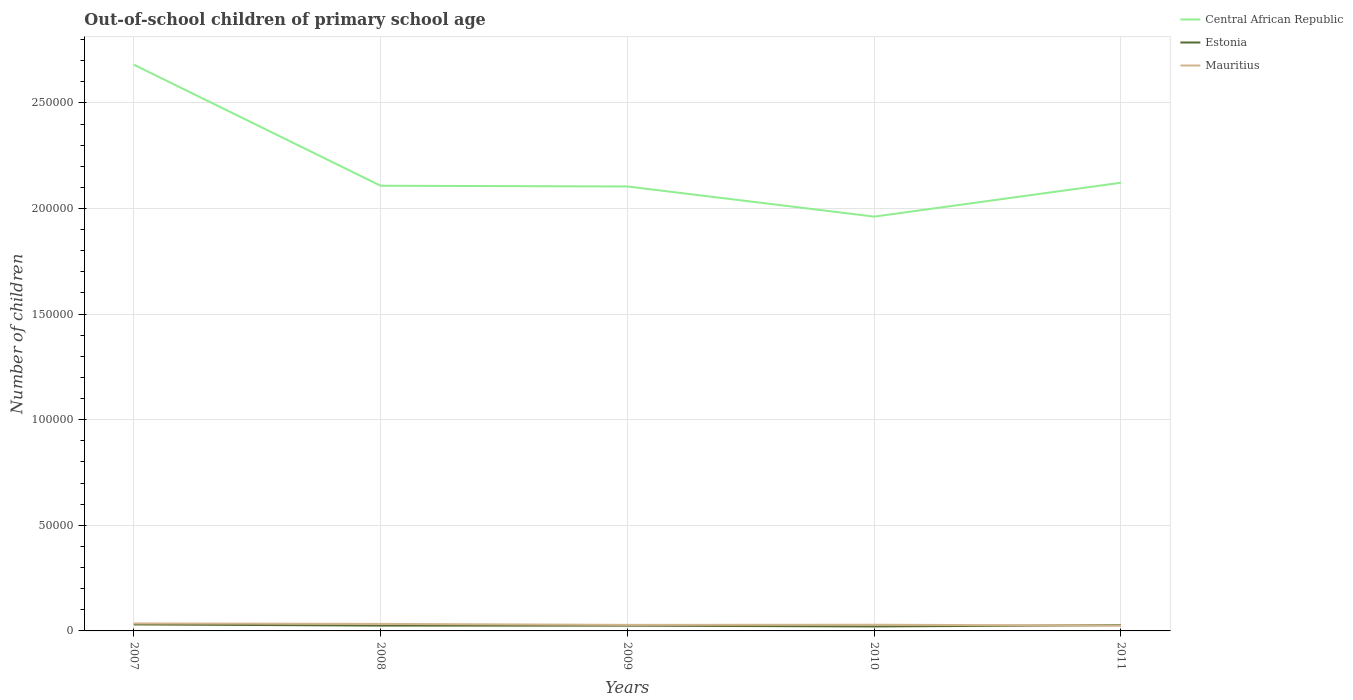How many different coloured lines are there?
Make the answer very short. 3. Across all years, what is the maximum number of out-of-school children in Estonia?
Provide a short and direct response. 2112. In which year was the number of out-of-school children in Estonia maximum?
Give a very brief answer. 2010. What is the total number of out-of-school children in Central African Republic in the graph?
Offer a very short reply. 342. What is the difference between the highest and the second highest number of out-of-school children in Central African Republic?
Offer a very short reply. 7.19e+04. Are the values on the major ticks of Y-axis written in scientific E-notation?
Keep it short and to the point. No. Does the graph contain any zero values?
Your answer should be compact. No. How many legend labels are there?
Provide a short and direct response. 3. How are the legend labels stacked?
Your answer should be very brief. Vertical. What is the title of the graph?
Keep it short and to the point. Out-of-school children of primary school age. What is the label or title of the Y-axis?
Your response must be concise. Number of children. What is the Number of children in Central African Republic in 2007?
Your response must be concise. 2.68e+05. What is the Number of children in Estonia in 2007?
Your answer should be compact. 3067. What is the Number of children of Mauritius in 2007?
Give a very brief answer. 3542. What is the Number of children in Central African Republic in 2008?
Provide a short and direct response. 2.11e+05. What is the Number of children in Estonia in 2008?
Provide a short and direct response. 2521. What is the Number of children of Mauritius in 2008?
Offer a terse response. 3326. What is the Number of children of Central African Republic in 2009?
Offer a very short reply. 2.10e+05. What is the Number of children in Estonia in 2009?
Give a very brief answer. 2495. What is the Number of children in Mauritius in 2009?
Your answer should be very brief. 2858. What is the Number of children in Central African Republic in 2010?
Make the answer very short. 1.96e+05. What is the Number of children of Estonia in 2010?
Ensure brevity in your answer.  2112. What is the Number of children in Mauritius in 2010?
Your answer should be compact. 2929. What is the Number of children in Central African Republic in 2011?
Offer a very short reply. 2.12e+05. What is the Number of children in Estonia in 2011?
Your answer should be compact. 2728. What is the Number of children in Mauritius in 2011?
Make the answer very short. 2516. Across all years, what is the maximum Number of children in Central African Republic?
Provide a succinct answer. 2.68e+05. Across all years, what is the maximum Number of children in Estonia?
Ensure brevity in your answer.  3067. Across all years, what is the maximum Number of children of Mauritius?
Provide a short and direct response. 3542. Across all years, what is the minimum Number of children in Central African Republic?
Provide a succinct answer. 1.96e+05. Across all years, what is the minimum Number of children of Estonia?
Offer a terse response. 2112. Across all years, what is the minimum Number of children of Mauritius?
Offer a very short reply. 2516. What is the total Number of children in Central African Republic in the graph?
Offer a very short reply. 1.10e+06. What is the total Number of children in Estonia in the graph?
Make the answer very short. 1.29e+04. What is the total Number of children in Mauritius in the graph?
Your response must be concise. 1.52e+04. What is the difference between the Number of children of Central African Republic in 2007 and that in 2008?
Give a very brief answer. 5.73e+04. What is the difference between the Number of children of Estonia in 2007 and that in 2008?
Provide a succinct answer. 546. What is the difference between the Number of children in Mauritius in 2007 and that in 2008?
Your response must be concise. 216. What is the difference between the Number of children of Central African Republic in 2007 and that in 2009?
Your answer should be very brief. 5.77e+04. What is the difference between the Number of children in Estonia in 2007 and that in 2009?
Your answer should be compact. 572. What is the difference between the Number of children of Mauritius in 2007 and that in 2009?
Offer a very short reply. 684. What is the difference between the Number of children of Central African Republic in 2007 and that in 2010?
Ensure brevity in your answer.  7.19e+04. What is the difference between the Number of children of Estonia in 2007 and that in 2010?
Offer a very short reply. 955. What is the difference between the Number of children in Mauritius in 2007 and that in 2010?
Give a very brief answer. 613. What is the difference between the Number of children of Central African Republic in 2007 and that in 2011?
Give a very brief answer. 5.59e+04. What is the difference between the Number of children of Estonia in 2007 and that in 2011?
Offer a very short reply. 339. What is the difference between the Number of children of Mauritius in 2007 and that in 2011?
Keep it short and to the point. 1026. What is the difference between the Number of children in Central African Republic in 2008 and that in 2009?
Make the answer very short. 342. What is the difference between the Number of children in Mauritius in 2008 and that in 2009?
Your response must be concise. 468. What is the difference between the Number of children in Central African Republic in 2008 and that in 2010?
Offer a very short reply. 1.46e+04. What is the difference between the Number of children in Estonia in 2008 and that in 2010?
Your response must be concise. 409. What is the difference between the Number of children in Mauritius in 2008 and that in 2010?
Provide a short and direct response. 397. What is the difference between the Number of children of Central African Republic in 2008 and that in 2011?
Provide a succinct answer. -1428. What is the difference between the Number of children of Estonia in 2008 and that in 2011?
Keep it short and to the point. -207. What is the difference between the Number of children in Mauritius in 2008 and that in 2011?
Provide a succinct answer. 810. What is the difference between the Number of children of Central African Republic in 2009 and that in 2010?
Provide a succinct answer. 1.43e+04. What is the difference between the Number of children of Estonia in 2009 and that in 2010?
Your answer should be very brief. 383. What is the difference between the Number of children of Mauritius in 2009 and that in 2010?
Keep it short and to the point. -71. What is the difference between the Number of children in Central African Republic in 2009 and that in 2011?
Give a very brief answer. -1770. What is the difference between the Number of children in Estonia in 2009 and that in 2011?
Your answer should be very brief. -233. What is the difference between the Number of children in Mauritius in 2009 and that in 2011?
Ensure brevity in your answer.  342. What is the difference between the Number of children of Central African Republic in 2010 and that in 2011?
Offer a very short reply. -1.60e+04. What is the difference between the Number of children in Estonia in 2010 and that in 2011?
Provide a succinct answer. -616. What is the difference between the Number of children in Mauritius in 2010 and that in 2011?
Give a very brief answer. 413. What is the difference between the Number of children of Central African Republic in 2007 and the Number of children of Estonia in 2008?
Ensure brevity in your answer.  2.66e+05. What is the difference between the Number of children in Central African Republic in 2007 and the Number of children in Mauritius in 2008?
Make the answer very short. 2.65e+05. What is the difference between the Number of children of Estonia in 2007 and the Number of children of Mauritius in 2008?
Keep it short and to the point. -259. What is the difference between the Number of children of Central African Republic in 2007 and the Number of children of Estonia in 2009?
Keep it short and to the point. 2.66e+05. What is the difference between the Number of children in Central African Republic in 2007 and the Number of children in Mauritius in 2009?
Provide a succinct answer. 2.65e+05. What is the difference between the Number of children in Estonia in 2007 and the Number of children in Mauritius in 2009?
Ensure brevity in your answer.  209. What is the difference between the Number of children of Central African Republic in 2007 and the Number of children of Estonia in 2010?
Offer a terse response. 2.66e+05. What is the difference between the Number of children in Central African Republic in 2007 and the Number of children in Mauritius in 2010?
Give a very brief answer. 2.65e+05. What is the difference between the Number of children in Estonia in 2007 and the Number of children in Mauritius in 2010?
Your answer should be very brief. 138. What is the difference between the Number of children in Central African Republic in 2007 and the Number of children in Estonia in 2011?
Make the answer very short. 2.65e+05. What is the difference between the Number of children of Central African Republic in 2007 and the Number of children of Mauritius in 2011?
Make the answer very short. 2.66e+05. What is the difference between the Number of children of Estonia in 2007 and the Number of children of Mauritius in 2011?
Ensure brevity in your answer.  551. What is the difference between the Number of children in Central African Republic in 2008 and the Number of children in Estonia in 2009?
Give a very brief answer. 2.08e+05. What is the difference between the Number of children of Central African Republic in 2008 and the Number of children of Mauritius in 2009?
Offer a terse response. 2.08e+05. What is the difference between the Number of children of Estonia in 2008 and the Number of children of Mauritius in 2009?
Give a very brief answer. -337. What is the difference between the Number of children of Central African Republic in 2008 and the Number of children of Estonia in 2010?
Offer a terse response. 2.09e+05. What is the difference between the Number of children of Central African Republic in 2008 and the Number of children of Mauritius in 2010?
Offer a very short reply. 2.08e+05. What is the difference between the Number of children in Estonia in 2008 and the Number of children in Mauritius in 2010?
Offer a terse response. -408. What is the difference between the Number of children of Central African Republic in 2008 and the Number of children of Estonia in 2011?
Keep it short and to the point. 2.08e+05. What is the difference between the Number of children of Central African Republic in 2008 and the Number of children of Mauritius in 2011?
Provide a succinct answer. 2.08e+05. What is the difference between the Number of children of Estonia in 2008 and the Number of children of Mauritius in 2011?
Offer a terse response. 5. What is the difference between the Number of children of Central African Republic in 2009 and the Number of children of Estonia in 2010?
Your answer should be very brief. 2.08e+05. What is the difference between the Number of children of Central African Republic in 2009 and the Number of children of Mauritius in 2010?
Give a very brief answer. 2.08e+05. What is the difference between the Number of children in Estonia in 2009 and the Number of children in Mauritius in 2010?
Offer a terse response. -434. What is the difference between the Number of children in Central African Republic in 2009 and the Number of children in Estonia in 2011?
Give a very brief answer. 2.08e+05. What is the difference between the Number of children of Central African Republic in 2009 and the Number of children of Mauritius in 2011?
Your response must be concise. 2.08e+05. What is the difference between the Number of children in Estonia in 2009 and the Number of children in Mauritius in 2011?
Offer a terse response. -21. What is the difference between the Number of children of Central African Republic in 2010 and the Number of children of Estonia in 2011?
Offer a very short reply. 1.93e+05. What is the difference between the Number of children of Central African Republic in 2010 and the Number of children of Mauritius in 2011?
Offer a very short reply. 1.94e+05. What is the difference between the Number of children of Estonia in 2010 and the Number of children of Mauritius in 2011?
Your answer should be compact. -404. What is the average Number of children in Central African Republic per year?
Offer a very short reply. 2.20e+05. What is the average Number of children in Estonia per year?
Your answer should be very brief. 2584.6. What is the average Number of children of Mauritius per year?
Ensure brevity in your answer.  3034.2. In the year 2007, what is the difference between the Number of children in Central African Republic and Number of children in Estonia?
Provide a short and direct response. 2.65e+05. In the year 2007, what is the difference between the Number of children of Central African Republic and Number of children of Mauritius?
Make the answer very short. 2.65e+05. In the year 2007, what is the difference between the Number of children of Estonia and Number of children of Mauritius?
Make the answer very short. -475. In the year 2008, what is the difference between the Number of children of Central African Republic and Number of children of Estonia?
Your response must be concise. 2.08e+05. In the year 2008, what is the difference between the Number of children in Central African Republic and Number of children in Mauritius?
Ensure brevity in your answer.  2.07e+05. In the year 2008, what is the difference between the Number of children in Estonia and Number of children in Mauritius?
Offer a terse response. -805. In the year 2009, what is the difference between the Number of children of Central African Republic and Number of children of Estonia?
Keep it short and to the point. 2.08e+05. In the year 2009, what is the difference between the Number of children in Central African Republic and Number of children in Mauritius?
Your answer should be very brief. 2.08e+05. In the year 2009, what is the difference between the Number of children of Estonia and Number of children of Mauritius?
Keep it short and to the point. -363. In the year 2010, what is the difference between the Number of children of Central African Republic and Number of children of Estonia?
Give a very brief answer. 1.94e+05. In the year 2010, what is the difference between the Number of children in Central African Republic and Number of children in Mauritius?
Your response must be concise. 1.93e+05. In the year 2010, what is the difference between the Number of children of Estonia and Number of children of Mauritius?
Make the answer very short. -817. In the year 2011, what is the difference between the Number of children of Central African Republic and Number of children of Estonia?
Provide a short and direct response. 2.09e+05. In the year 2011, what is the difference between the Number of children in Central African Republic and Number of children in Mauritius?
Provide a short and direct response. 2.10e+05. In the year 2011, what is the difference between the Number of children in Estonia and Number of children in Mauritius?
Provide a short and direct response. 212. What is the ratio of the Number of children of Central African Republic in 2007 to that in 2008?
Your response must be concise. 1.27. What is the ratio of the Number of children of Estonia in 2007 to that in 2008?
Keep it short and to the point. 1.22. What is the ratio of the Number of children in Mauritius in 2007 to that in 2008?
Your answer should be compact. 1.06. What is the ratio of the Number of children of Central African Republic in 2007 to that in 2009?
Offer a terse response. 1.27. What is the ratio of the Number of children in Estonia in 2007 to that in 2009?
Your answer should be compact. 1.23. What is the ratio of the Number of children in Mauritius in 2007 to that in 2009?
Provide a short and direct response. 1.24. What is the ratio of the Number of children in Central African Republic in 2007 to that in 2010?
Keep it short and to the point. 1.37. What is the ratio of the Number of children in Estonia in 2007 to that in 2010?
Keep it short and to the point. 1.45. What is the ratio of the Number of children in Mauritius in 2007 to that in 2010?
Your response must be concise. 1.21. What is the ratio of the Number of children in Central African Republic in 2007 to that in 2011?
Keep it short and to the point. 1.26. What is the ratio of the Number of children in Estonia in 2007 to that in 2011?
Keep it short and to the point. 1.12. What is the ratio of the Number of children in Mauritius in 2007 to that in 2011?
Provide a succinct answer. 1.41. What is the ratio of the Number of children of Estonia in 2008 to that in 2009?
Give a very brief answer. 1.01. What is the ratio of the Number of children in Mauritius in 2008 to that in 2009?
Provide a short and direct response. 1.16. What is the ratio of the Number of children of Central African Republic in 2008 to that in 2010?
Offer a terse response. 1.07. What is the ratio of the Number of children of Estonia in 2008 to that in 2010?
Ensure brevity in your answer.  1.19. What is the ratio of the Number of children in Mauritius in 2008 to that in 2010?
Make the answer very short. 1.14. What is the ratio of the Number of children in Estonia in 2008 to that in 2011?
Keep it short and to the point. 0.92. What is the ratio of the Number of children in Mauritius in 2008 to that in 2011?
Offer a very short reply. 1.32. What is the ratio of the Number of children of Central African Republic in 2009 to that in 2010?
Give a very brief answer. 1.07. What is the ratio of the Number of children of Estonia in 2009 to that in 2010?
Make the answer very short. 1.18. What is the ratio of the Number of children of Mauritius in 2009 to that in 2010?
Ensure brevity in your answer.  0.98. What is the ratio of the Number of children in Estonia in 2009 to that in 2011?
Your answer should be compact. 0.91. What is the ratio of the Number of children in Mauritius in 2009 to that in 2011?
Ensure brevity in your answer.  1.14. What is the ratio of the Number of children of Central African Republic in 2010 to that in 2011?
Give a very brief answer. 0.92. What is the ratio of the Number of children of Estonia in 2010 to that in 2011?
Your answer should be compact. 0.77. What is the ratio of the Number of children in Mauritius in 2010 to that in 2011?
Ensure brevity in your answer.  1.16. What is the difference between the highest and the second highest Number of children of Central African Republic?
Give a very brief answer. 5.59e+04. What is the difference between the highest and the second highest Number of children in Estonia?
Provide a short and direct response. 339. What is the difference between the highest and the second highest Number of children of Mauritius?
Offer a very short reply. 216. What is the difference between the highest and the lowest Number of children of Central African Republic?
Provide a succinct answer. 7.19e+04. What is the difference between the highest and the lowest Number of children in Estonia?
Your answer should be compact. 955. What is the difference between the highest and the lowest Number of children in Mauritius?
Your answer should be very brief. 1026. 